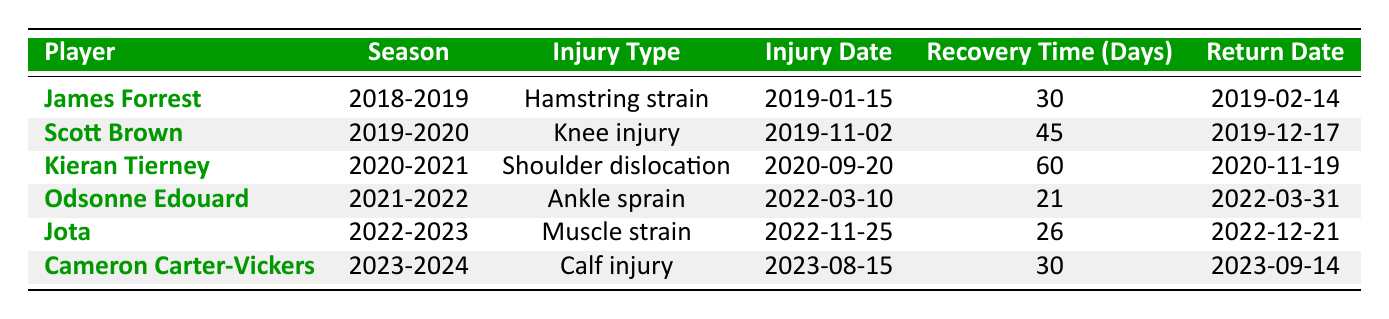What was the recovery time for James Forrest? James Forrest's injury report from the 2018-2019 season shows he had a hamstring strain with a recovery time of 30 days.
Answer: 30 days Which player had the longest recovery time? Kieran Tierney had the longest recovery time of 60 days for his shoulder dislocation in the 2020-2021 season.
Answer: Kieran Tierney Is there any player who returned from injury in less than 30 days? Odsonne Edouard returned from his ankle sprain in 21 days, which is less than 30 days.
Answer: Yes How many players had injuries during the 2019-2020 season? According to the table, Scott Brown is the only player listed with an injury in the 2019-2020 season.
Answer: 1 player What is the average recovery time for the players in the table? To calculate the average recovery time, sum the recovery times: 30 + 45 + 60 + 21 + 26 + 30 = 212. There are 6 players, so the average is 212 / 6 = approximately 35.33 days.
Answer: 35.33 days Which injury type had the least recovery time and which player experienced it? Odsonne Edouard's ankle sprain had the least recovery time of 21 days, which is the shortest duration among all injuries listed.
Answer: Ankle sprain, Odsonne Edouard Did any player return on the same day they got injured? No, all players had recovery periods before returning to play. The shortest recovery time was 21 days.
Answer: No How many players suffered calf injuries, and what was their recovery time? Only Cameron Carter-Vickers suffered a calf injury, and his recovery time was 30 days.
Answer: 1 player, 30 days What is the recovery time difference between Scott Brown and Jota? Scott Brown had a recovery time of 45 days, while Jota had 26 days. The difference is 45 - 26 = 19 days.
Answer: 19 days What was the return date for Kieran Tierney? Kieran Tierney returned from his shoulder dislocation on 2020-11-19.
Answer: 2020-11-19 